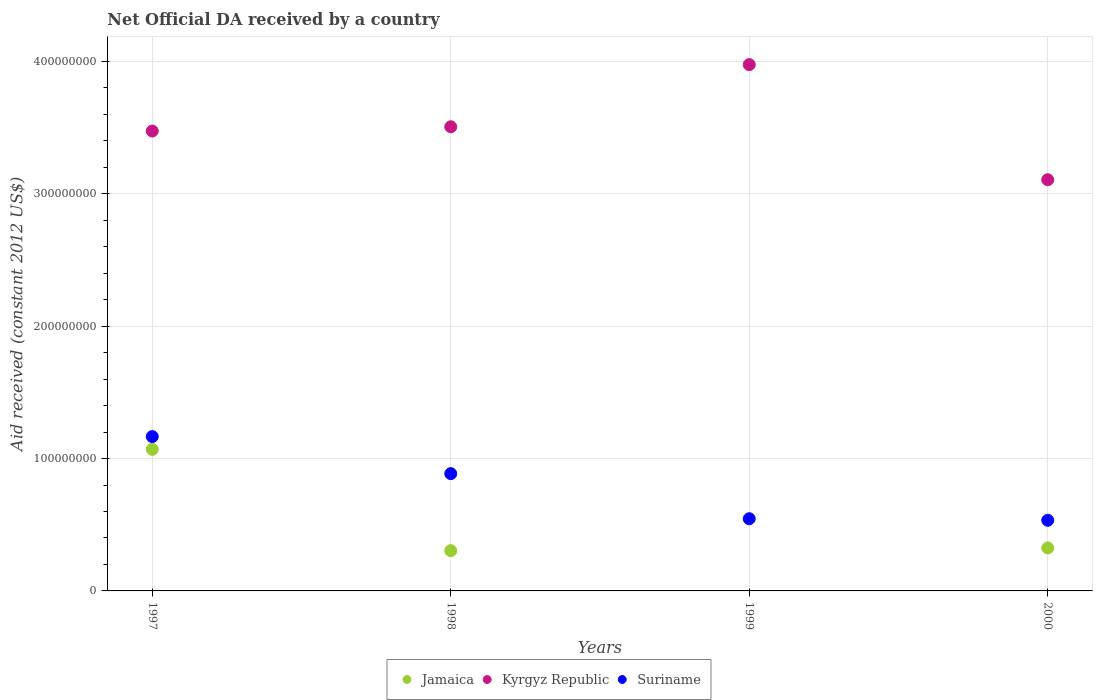Is the number of dotlines equal to the number of legend labels?
Offer a terse response. No. What is the net official development assistance aid received in Jamaica in 1997?
Make the answer very short. 1.07e+08. Across all years, what is the maximum net official development assistance aid received in Kyrgyz Republic?
Make the answer very short. 3.98e+08. Across all years, what is the minimum net official development assistance aid received in Suriname?
Provide a short and direct response. 5.34e+07. What is the total net official development assistance aid received in Jamaica in the graph?
Offer a terse response. 1.70e+08. What is the difference between the net official development assistance aid received in Kyrgyz Republic in 1997 and that in 1999?
Make the answer very short. -5.02e+07. What is the difference between the net official development assistance aid received in Kyrgyz Republic in 1998 and the net official development assistance aid received in Suriname in 1997?
Provide a succinct answer. 2.34e+08. What is the average net official development assistance aid received in Suriname per year?
Your answer should be very brief. 7.83e+07. In the year 2000, what is the difference between the net official development assistance aid received in Suriname and net official development assistance aid received in Kyrgyz Republic?
Keep it short and to the point. -2.57e+08. What is the ratio of the net official development assistance aid received in Suriname in 1999 to that in 2000?
Offer a terse response. 1.02. Is the net official development assistance aid received in Jamaica in 1998 less than that in 2000?
Give a very brief answer. Yes. Is the difference between the net official development assistance aid received in Suriname in 1998 and 1999 greater than the difference between the net official development assistance aid received in Kyrgyz Republic in 1998 and 1999?
Provide a succinct answer. Yes. What is the difference between the highest and the second highest net official development assistance aid received in Suriname?
Make the answer very short. 2.80e+07. What is the difference between the highest and the lowest net official development assistance aid received in Suriname?
Offer a very short reply. 6.32e+07. In how many years, is the net official development assistance aid received in Jamaica greater than the average net official development assistance aid received in Jamaica taken over all years?
Provide a succinct answer. 1. Is the sum of the net official development assistance aid received in Jamaica in 1997 and 1998 greater than the maximum net official development assistance aid received in Suriname across all years?
Your response must be concise. Yes. How many dotlines are there?
Your answer should be compact. 3. Does the graph contain any zero values?
Make the answer very short. Yes. Does the graph contain grids?
Keep it short and to the point. Yes. What is the title of the graph?
Offer a terse response. Net Official DA received by a country. What is the label or title of the Y-axis?
Your answer should be very brief. Aid received (constant 2012 US$). What is the Aid received (constant 2012 US$) in Jamaica in 1997?
Your response must be concise. 1.07e+08. What is the Aid received (constant 2012 US$) in Kyrgyz Republic in 1997?
Offer a terse response. 3.47e+08. What is the Aid received (constant 2012 US$) in Suriname in 1997?
Your response must be concise. 1.17e+08. What is the Aid received (constant 2012 US$) of Jamaica in 1998?
Provide a short and direct response. 3.04e+07. What is the Aid received (constant 2012 US$) of Kyrgyz Republic in 1998?
Make the answer very short. 3.51e+08. What is the Aid received (constant 2012 US$) in Suriname in 1998?
Provide a succinct answer. 8.86e+07. What is the Aid received (constant 2012 US$) of Kyrgyz Republic in 1999?
Provide a succinct answer. 3.98e+08. What is the Aid received (constant 2012 US$) in Suriname in 1999?
Provide a succinct answer. 5.45e+07. What is the Aid received (constant 2012 US$) in Jamaica in 2000?
Give a very brief answer. 3.25e+07. What is the Aid received (constant 2012 US$) in Kyrgyz Republic in 2000?
Offer a very short reply. 3.11e+08. What is the Aid received (constant 2012 US$) of Suriname in 2000?
Your response must be concise. 5.34e+07. Across all years, what is the maximum Aid received (constant 2012 US$) of Jamaica?
Offer a very short reply. 1.07e+08. Across all years, what is the maximum Aid received (constant 2012 US$) in Kyrgyz Republic?
Provide a succinct answer. 3.98e+08. Across all years, what is the maximum Aid received (constant 2012 US$) in Suriname?
Your response must be concise. 1.17e+08. Across all years, what is the minimum Aid received (constant 2012 US$) of Jamaica?
Your answer should be very brief. 0. Across all years, what is the minimum Aid received (constant 2012 US$) of Kyrgyz Republic?
Offer a terse response. 3.11e+08. Across all years, what is the minimum Aid received (constant 2012 US$) in Suriname?
Your response must be concise. 5.34e+07. What is the total Aid received (constant 2012 US$) in Jamaica in the graph?
Make the answer very short. 1.70e+08. What is the total Aid received (constant 2012 US$) of Kyrgyz Republic in the graph?
Offer a terse response. 1.41e+09. What is the total Aid received (constant 2012 US$) in Suriname in the graph?
Ensure brevity in your answer.  3.13e+08. What is the difference between the Aid received (constant 2012 US$) of Jamaica in 1997 and that in 1998?
Your answer should be compact. 7.65e+07. What is the difference between the Aid received (constant 2012 US$) of Kyrgyz Republic in 1997 and that in 1998?
Provide a short and direct response. -3.21e+06. What is the difference between the Aid received (constant 2012 US$) in Suriname in 1997 and that in 1998?
Make the answer very short. 2.80e+07. What is the difference between the Aid received (constant 2012 US$) in Kyrgyz Republic in 1997 and that in 1999?
Provide a succinct answer. -5.02e+07. What is the difference between the Aid received (constant 2012 US$) in Suriname in 1997 and that in 1999?
Keep it short and to the point. 6.21e+07. What is the difference between the Aid received (constant 2012 US$) of Jamaica in 1997 and that in 2000?
Provide a short and direct response. 7.45e+07. What is the difference between the Aid received (constant 2012 US$) of Kyrgyz Republic in 1997 and that in 2000?
Give a very brief answer. 3.68e+07. What is the difference between the Aid received (constant 2012 US$) of Suriname in 1997 and that in 2000?
Your answer should be compact. 6.32e+07. What is the difference between the Aid received (constant 2012 US$) in Kyrgyz Republic in 1998 and that in 1999?
Your answer should be compact. -4.70e+07. What is the difference between the Aid received (constant 2012 US$) of Suriname in 1998 and that in 1999?
Make the answer very short. 3.41e+07. What is the difference between the Aid received (constant 2012 US$) in Jamaica in 1998 and that in 2000?
Your answer should be compact. -2.04e+06. What is the difference between the Aid received (constant 2012 US$) of Kyrgyz Republic in 1998 and that in 2000?
Your answer should be very brief. 4.00e+07. What is the difference between the Aid received (constant 2012 US$) of Suriname in 1998 and that in 2000?
Keep it short and to the point. 3.52e+07. What is the difference between the Aid received (constant 2012 US$) in Kyrgyz Republic in 1999 and that in 2000?
Ensure brevity in your answer.  8.70e+07. What is the difference between the Aid received (constant 2012 US$) in Suriname in 1999 and that in 2000?
Give a very brief answer. 1.18e+06. What is the difference between the Aid received (constant 2012 US$) in Jamaica in 1997 and the Aid received (constant 2012 US$) in Kyrgyz Republic in 1998?
Offer a very short reply. -2.44e+08. What is the difference between the Aid received (constant 2012 US$) of Jamaica in 1997 and the Aid received (constant 2012 US$) of Suriname in 1998?
Your answer should be compact. 1.84e+07. What is the difference between the Aid received (constant 2012 US$) in Kyrgyz Republic in 1997 and the Aid received (constant 2012 US$) in Suriname in 1998?
Provide a succinct answer. 2.59e+08. What is the difference between the Aid received (constant 2012 US$) of Jamaica in 1997 and the Aid received (constant 2012 US$) of Kyrgyz Republic in 1999?
Offer a terse response. -2.91e+08. What is the difference between the Aid received (constant 2012 US$) in Jamaica in 1997 and the Aid received (constant 2012 US$) in Suriname in 1999?
Provide a short and direct response. 5.24e+07. What is the difference between the Aid received (constant 2012 US$) in Kyrgyz Republic in 1997 and the Aid received (constant 2012 US$) in Suriname in 1999?
Offer a very short reply. 2.93e+08. What is the difference between the Aid received (constant 2012 US$) in Jamaica in 1997 and the Aid received (constant 2012 US$) in Kyrgyz Republic in 2000?
Your answer should be compact. -2.04e+08. What is the difference between the Aid received (constant 2012 US$) of Jamaica in 1997 and the Aid received (constant 2012 US$) of Suriname in 2000?
Give a very brief answer. 5.36e+07. What is the difference between the Aid received (constant 2012 US$) in Kyrgyz Republic in 1997 and the Aid received (constant 2012 US$) in Suriname in 2000?
Offer a very short reply. 2.94e+08. What is the difference between the Aid received (constant 2012 US$) of Jamaica in 1998 and the Aid received (constant 2012 US$) of Kyrgyz Republic in 1999?
Provide a succinct answer. -3.67e+08. What is the difference between the Aid received (constant 2012 US$) in Jamaica in 1998 and the Aid received (constant 2012 US$) in Suriname in 1999?
Make the answer very short. -2.41e+07. What is the difference between the Aid received (constant 2012 US$) in Kyrgyz Republic in 1998 and the Aid received (constant 2012 US$) in Suriname in 1999?
Your answer should be compact. 2.96e+08. What is the difference between the Aid received (constant 2012 US$) of Jamaica in 1998 and the Aid received (constant 2012 US$) of Kyrgyz Republic in 2000?
Make the answer very short. -2.80e+08. What is the difference between the Aid received (constant 2012 US$) of Jamaica in 1998 and the Aid received (constant 2012 US$) of Suriname in 2000?
Your answer should be compact. -2.29e+07. What is the difference between the Aid received (constant 2012 US$) in Kyrgyz Republic in 1998 and the Aid received (constant 2012 US$) in Suriname in 2000?
Make the answer very short. 2.97e+08. What is the difference between the Aid received (constant 2012 US$) of Kyrgyz Republic in 1999 and the Aid received (constant 2012 US$) of Suriname in 2000?
Provide a short and direct response. 3.44e+08. What is the average Aid received (constant 2012 US$) of Jamaica per year?
Provide a short and direct response. 4.25e+07. What is the average Aid received (constant 2012 US$) in Kyrgyz Republic per year?
Offer a very short reply. 3.52e+08. What is the average Aid received (constant 2012 US$) of Suriname per year?
Give a very brief answer. 7.83e+07. In the year 1997, what is the difference between the Aid received (constant 2012 US$) of Jamaica and Aid received (constant 2012 US$) of Kyrgyz Republic?
Provide a succinct answer. -2.40e+08. In the year 1997, what is the difference between the Aid received (constant 2012 US$) of Jamaica and Aid received (constant 2012 US$) of Suriname?
Ensure brevity in your answer.  -9.64e+06. In the year 1997, what is the difference between the Aid received (constant 2012 US$) in Kyrgyz Republic and Aid received (constant 2012 US$) in Suriname?
Your answer should be very brief. 2.31e+08. In the year 1998, what is the difference between the Aid received (constant 2012 US$) in Jamaica and Aid received (constant 2012 US$) in Kyrgyz Republic?
Make the answer very short. -3.20e+08. In the year 1998, what is the difference between the Aid received (constant 2012 US$) of Jamaica and Aid received (constant 2012 US$) of Suriname?
Keep it short and to the point. -5.82e+07. In the year 1998, what is the difference between the Aid received (constant 2012 US$) in Kyrgyz Republic and Aid received (constant 2012 US$) in Suriname?
Make the answer very short. 2.62e+08. In the year 1999, what is the difference between the Aid received (constant 2012 US$) in Kyrgyz Republic and Aid received (constant 2012 US$) in Suriname?
Provide a short and direct response. 3.43e+08. In the year 2000, what is the difference between the Aid received (constant 2012 US$) of Jamaica and Aid received (constant 2012 US$) of Kyrgyz Republic?
Offer a terse response. -2.78e+08. In the year 2000, what is the difference between the Aid received (constant 2012 US$) of Jamaica and Aid received (constant 2012 US$) of Suriname?
Offer a very short reply. -2.09e+07. In the year 2000, what is the difference between the Aid received (constant 2012 US$) in Kyrgyz Republic and Aid received (constant 2012 US$) in Suriname?
Offer a very short reply. 2.57e+08. What is the ratio of the Aid received (constant 2012 US$) of Jamaica in 1997 to that in 1998?
Make the answer very short. 3.51. What is the ratio of the Aid received (constant 2012 US$) in Kyrgyz Republic in 1997 to that in 1998?
Offer a very short reply. 0.99. What is the ratio of the Aid received (constant 2012 US$) of Suriname in 1997 to that in 1998?
Keep it short and to the point. 1.32. What is the ratio of the Aid received (constant 2012 US$) of Kyrgyz Republic in 1997 to that in 1999?
Provide a short and direct response. 0.87. What is the ratio of the Aid received (constant 2012 US$) in Suriname in 1997 to that in 1999?
Offer a very short reply. 2.14. What is the ratio of the Aid received (constant 2012 US$) of Jamaica in 1997 to that in 2000?
Provide a short and direct response. 3.29. What is the ratio of the Aid received (constant 2012 US$) in Kyrgyz Republic in 1997 to that in 2000?
Provide a short and direct response. 1.12. What is the ratio of the Aid received (constant 2012 US$) in Suriname in 1997 to that in 2000?
Your answer should be very brief. 2.19. What is the ratio of the Aid received (constant 2012 US$) of Kyrgyz Republic in 1998 to that in 1999?
Keep it short and to the point. 0.88. What is the ratio of the Aid received (constant 2012 US$) of Suriname in 1998 to that in 1999?
Your response must be concise. 1.62. What is the ratio of the Aid received (constant 2012 US$) in Jamaica in 1998 to that in 2000?
Give a very brief answer. 0.94. What is the ratio of the Aid received (constant 2012 US$) in Kyrgyz Republic in 1998 to that in 2000?
Provide a short and direct response. 1.13. What is the ratio of the Aid received (constant 2012 US$) of Suriname in 1998 to that in 2000?
Provide a succinct answer. 1.66. What is the ratio of the Aid received (constant 2012 US$) in Kyrgyz Republic in 1999 to that in 2000?
Give a very brief answer. 1.28. What is the ratio of the Aid received (constant 2012 US$) in Suriname in 1999 to that in 2000?
Make the answer very short. 1.02. What is the difference between the highest and the second highest Aid received (constant 2012 US$) in Jamaica?
Provide a short and direct response. 7.45e+07. What is the difference between the highest and the second highest Aid received (constant 2012 US$) in Kyrgyz Republic?
Keep it short and to the point. 4.70e+07. What is the difference between the highest and the second highest Aid received (constant 2012 US$) of Suriname?
Ensure brevity in your answer.  2.80e+07. What is the difference between the highest and the lowest Aid received (constant 2012 US$) of Jamaica?
Your answer should be compact. 1.07e+08. What is the difference between the highest and the lowest Aid received (constant 2012 US$) of Kyrgyz Republic?
Offer a terse response. 8.70e+07. What is the difference between the highest and the lowest Aid received (constant 2012 US$) in Suriname?
Keep it short and to the point. 6.32e+07. 